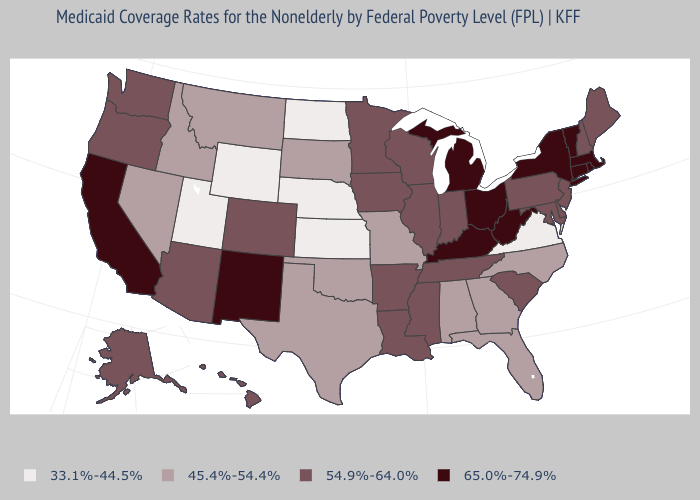Does Massachusetts have the same value as Kentucky?
Quick response, please. Yes. Does Texas have a higher value than Idaho?
Concise answer only. No. What is the value of Alabama?
Quick response, please. 45.4%-54.4%. What is the value of Montana?
Write a very short answer. 45.4%-54.4%. Is the legend a continuous bar?
Concise answer only. No. Among the states that border Montana , which have the lowest value?
Quick response, please. North Dakota, Wyoming. Name the states that have a value in the range 33.1%-44.5%?
Give a very brief answer. Kansas, Nebraska, North Dakota, Utah, Virginia, Wyoming. Name the states that have a value in the range 45.4%-54.4%?
Quick response, please. Alabama, Florida, Georgia, Idaho, Missouri, Montana, Nevada, North Carolina, Oklahoma, South Dakota, Texas. What is the highest value in the USA?
Give a very brief answer. 65.0%-74.9%. Does New Mexico have the highest value in the West?
Short answer required. Yes. Which states have the highest value in the USA?
Keep it brief. California, Connecticut, Kentucky, Massachusetts, Michigan, New Mexico, New York, Ohio, Rhode Island, Vermont, West Virginia. Does Tennessee have the lowest value in the South?
Be succinct. No. What is the value of Oregon?
Give a very brief answer. 54.9%-64.0%. Which states have the highest value in the USA?
Short answer required. California, Connecticut, Kentucky, Massachusetts, Michigan, New Mexico, New York, Ohio, Rhode Island, Vermont, West Virginia. Does Virginia have the lowest value in the South?
Concise answer only. Yes. 